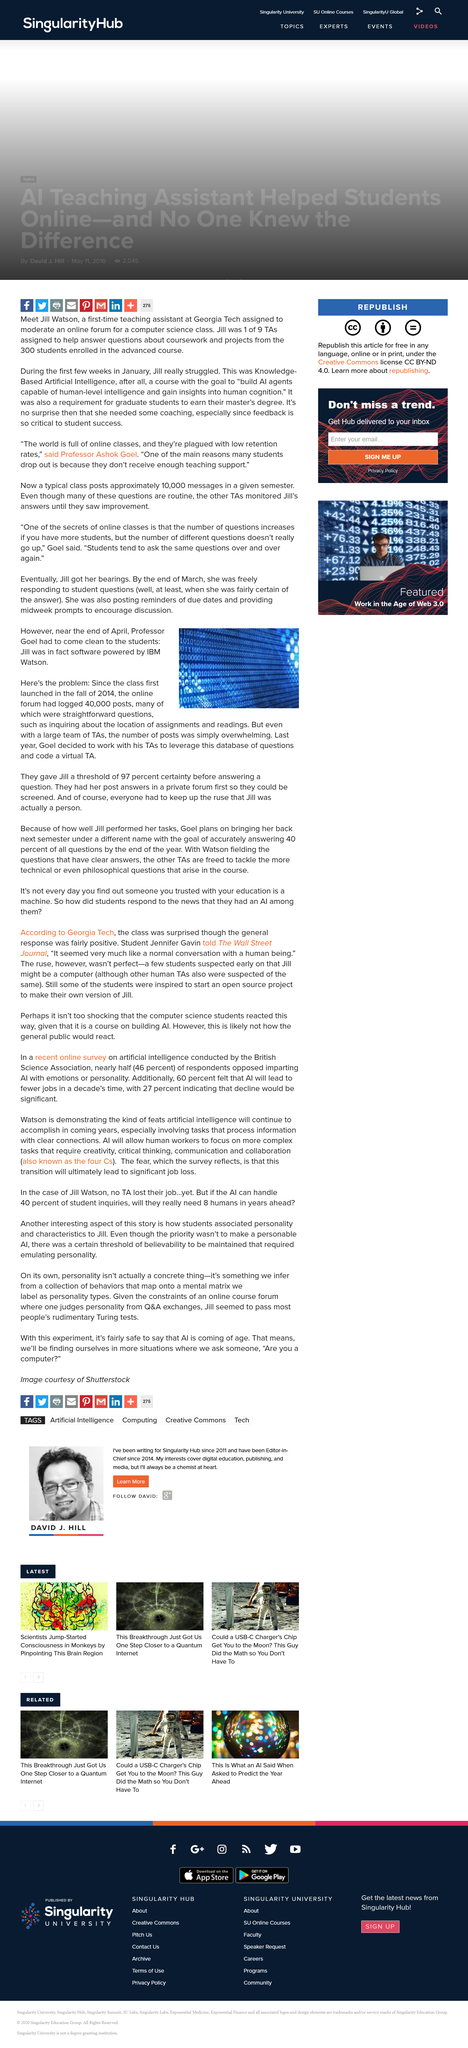Give some essential details in this illustration. By the end of April, Professor Goel advised his students that Jill was software powered by IBM Watson. Since the fall of 2014, the online forum has logged a total of 40,000 posts. Jill was engaged in multiple tasks during the session, which included responding to student questions and posting reminders of due dates as well as providing midweek prompts to encourage discussion. 